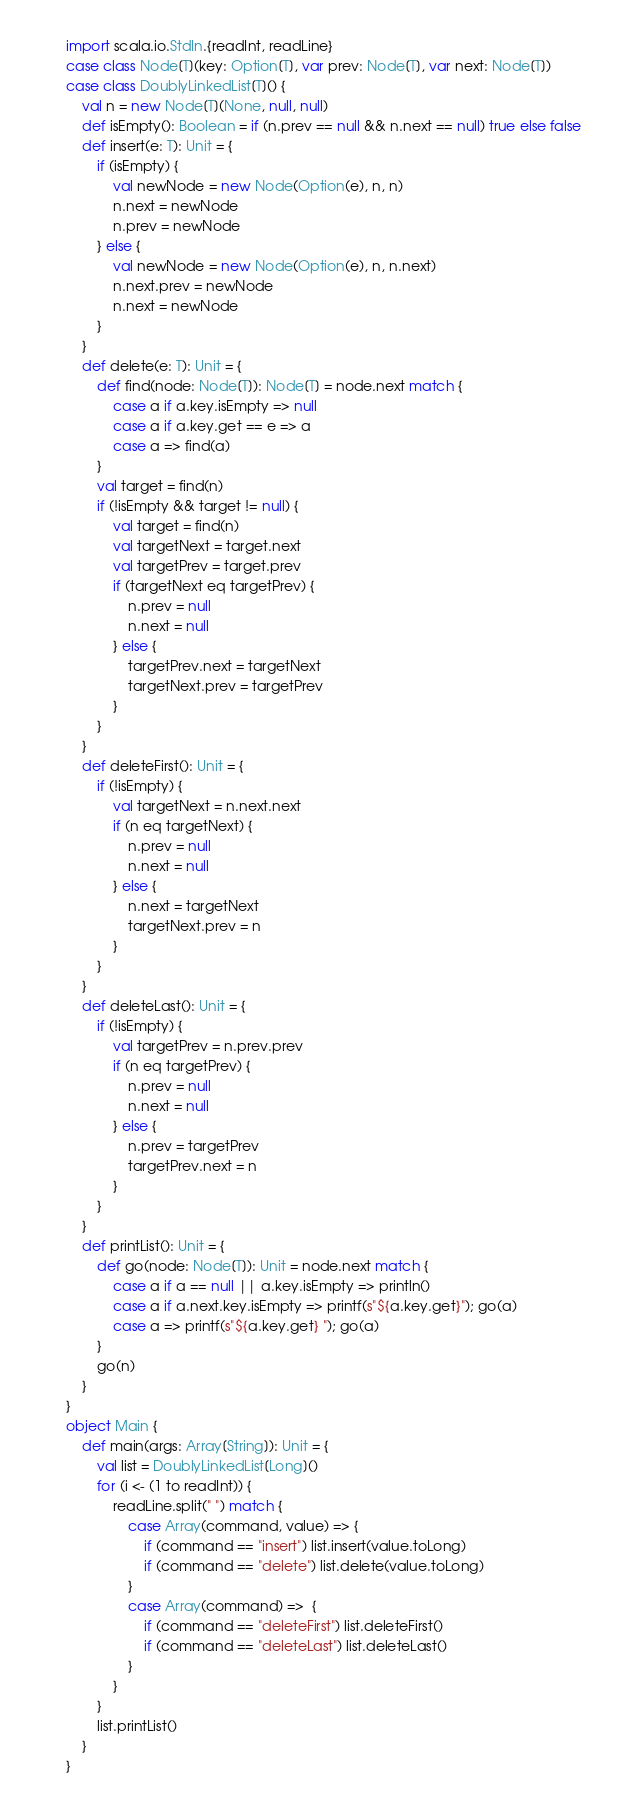Convert code to text. <code><loc_0><loc_0><loc_500><loc_500><_Scala_>import scala.io.StdIn.{readInt, readLine}
case class Node[T](key: Option[T], var prev: Node[T], var next: Node[T])
case class DoublyLinkedList[T]() {
    val n = new Node[T](None, null, null)
    def isEmpty(): Boolean = if (n.prev == null && n.next == null) true else false
    def insert(e: T): Unit = {
        if (isEmpty) {
            val newNode = new Node(Option(e), n, n)
            n.next = newNode
            n.prev = newNode
        } else {
            val newNode = new Node(Option(e), n, n.next)
            n.next.prev = newNode
            n.next = newNode
        }
    }
    def delete(e: T): Unit = {
        def find(node: Node[T]): Node[T] = node.next match {
            case a if a.key.isEmpty => null
            case a if a.key.get == e => a 
            case a => find(a)
        }
        val target = find(n)
        if (!isEmpty && target != null) {
            val target = find(n)
            val targetNext = target.next
            val targetPrev = target.prev
            if (targetNext eq targetPrev) {
                n.prev = null
                n.next = null
            } else {
                targetPrev.next = targetNext
                targetNext.prev = targetPrev
            }
        }
    }
    def deleteFirst(): Unit = {
        if (!isEmpty) {
            val targetNext = n.next.next
            if (n eq targetNext) {
                n.prev = null
                n.next = null
            } else {
                n.next = targetNext
                targetNext.prev = n
            }
        }
    }
    def deleteLast(): Unit = {
        if (!isEmpty) {
            val targetPrev = n.prev.prev
            if (n eq targetPrev) {
                n.prev = null
                n.next = null
            } else {
                n.prev = targetPrev
                targetPrev.next = n
            }
        }
    }
    def printList(): Unit = {
        def go(node: Node[T]): Unit = node.next match {
            case a if a == null || a.key.isEmpty => println()
            case a if a.next.key.isEmpty => printf(s"${a.key.get}"); go(a)
            case a => printf(s"${a.key.get} "); go(a)
        }
        go(n)
    }
}
object Main {
    def main(args: Array[String]): Unit = {
        val list = DoublyLinkedList[Long]()
        for (i <- (1 to readInt)) {
            readLine.split(" ") match {
                case Array(command, value) => {
                    if (command == "insert") list.insert(value.toLong)
                    if (command == "delete") list.delete(value.toLong)
                }
                case Array(command) =>  {
                    if (command == "deleteFirst") list.deleteFirst()
                    if (command == "deleteLast") list.deleteLast()
                }
            }
        }
        list.printList()
    }
}
</code> 